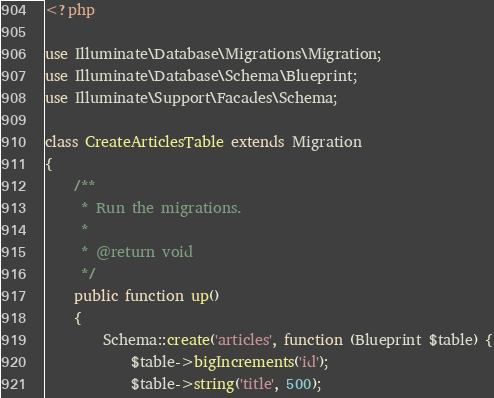<code> <loc_0><loc_0><loc_500><loc_500><_PHP_><?php

use Illuminate\Database\Migrations\Migration;
use Illuminate\Database\Schema\Blueprint;
use Illuminate\Support\Facades\Schema;

class CreateArticlesTable extends Migration
{
    /**
     * Run the migrations.
     *
     * @return void
     */
    public function up()
    {
        Schema::create('articles', function (Blueprint $table) {
            $table->bigIncrements('id');
            $table->string('title', 500);</code> 